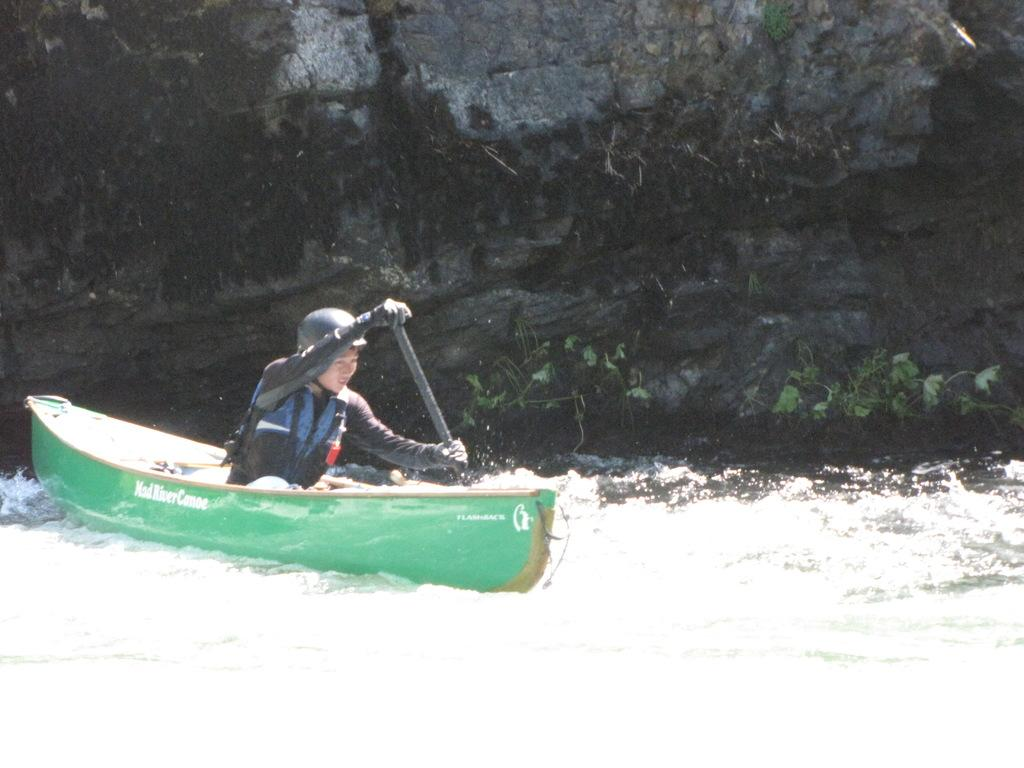Who is present in the image? There is a man in the image. What is the man doing in the image? The man is sitting on a boat and rowing in the water. What can be seen in the background of the image? There is a rock visible in the background of the image. How many grains of sand can be seen on the man's meal in the image? There is no meal or sand present in the image; the man is rowing a boat in the water. 